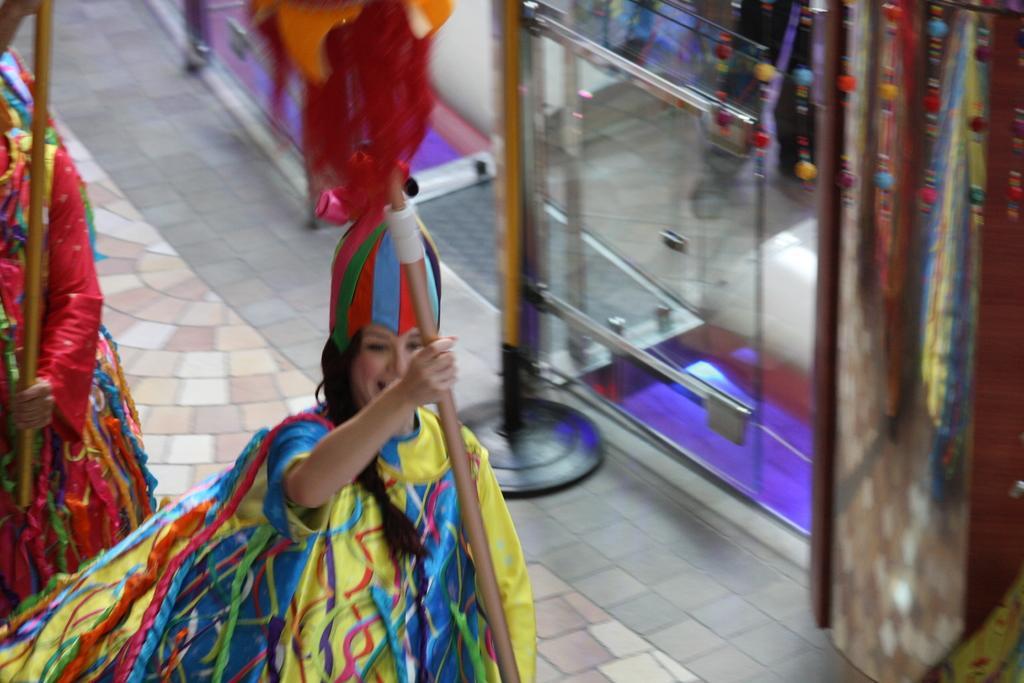How would you summarize this image in a sentence or two? In this picture I can see two persons standing and holding wooden sticks, and in the background there are some objects. 